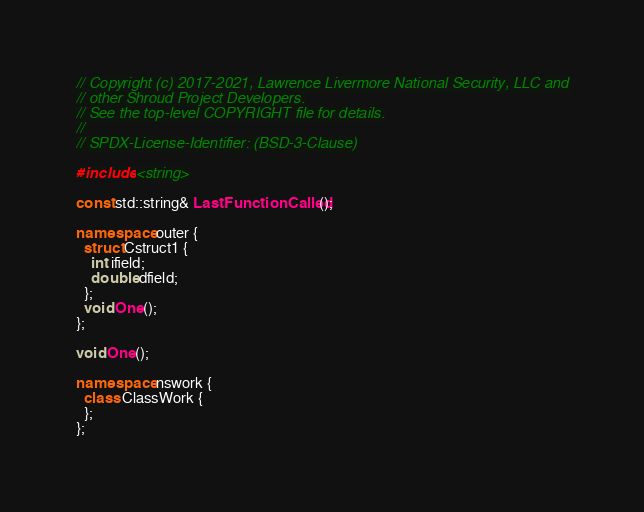<code> <loc_0><loc_0><loc_500><loc_500><_C++_>// Copyright (c) 2017-2021, Lawrence Livermore National Security, LLC and
// other Shroud Project Developers.
// See the top-level COPYRIGHT file for details.
//
// SPDX-License-Identifier: (BSD-3-Clause)

#include <string>

const std::string& LastFunctionCalled();

namespace outer {
  struct Cstruct1 {
    int ifield;
    double dfield;
  };
  void One();
};

void One();

namespace nswork {
  class ClassWork {
  };
};
</code> 